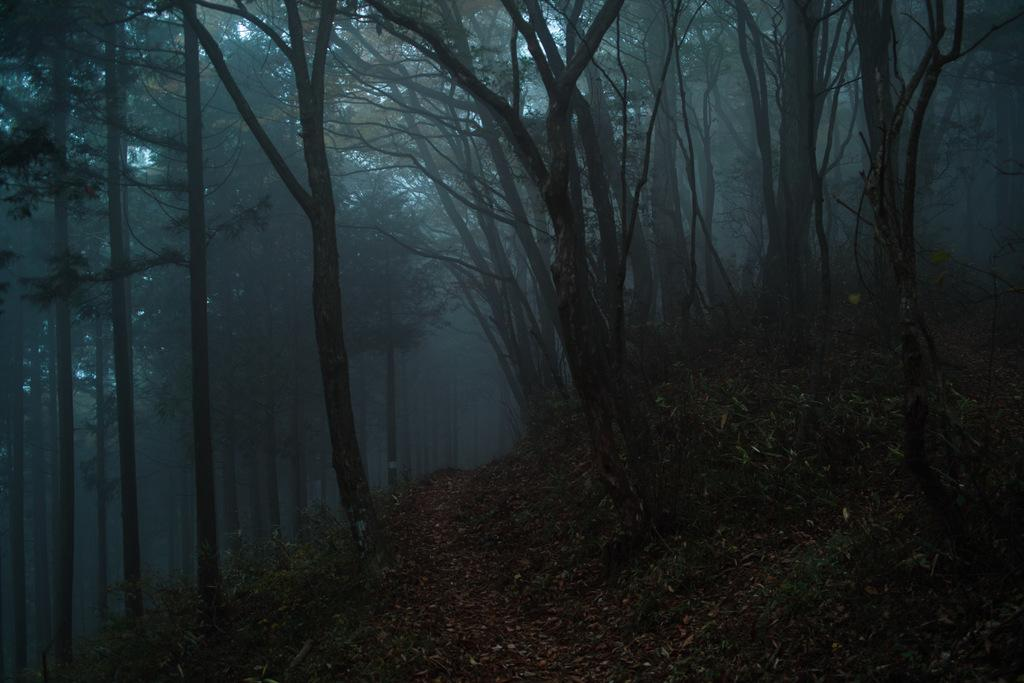What is located in the center of the image? There are trees, plants, and dry leaves in the center of the image. Can you describe the weather condition in the image? There is fog visible in the image, which suggests a cool or damp environment. What other objects can be seen in the center of the image? There are a few other objects in the center of the image, but their specific nature is not mentioned in the provided facts. What type of voice can be heard coming from the trees in the image? There is no voice present in the image; it only features visual elements such as trees, plants, dry leaves, and fog. 